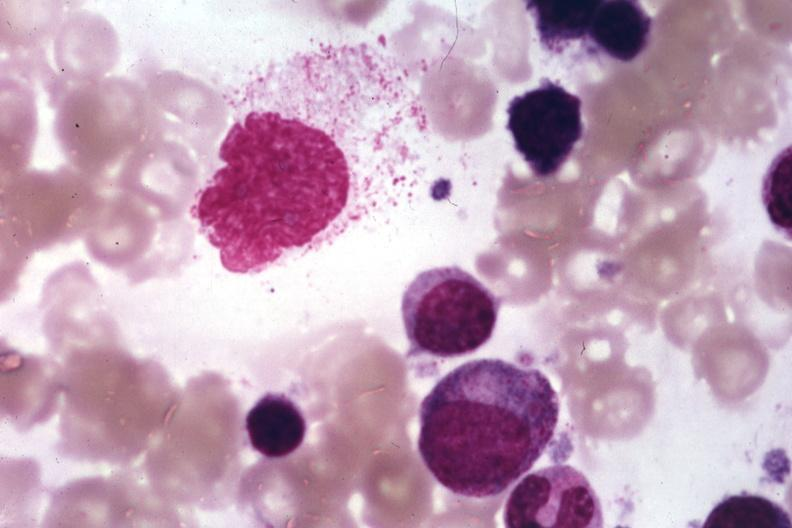s endocervical polyp present?
Answer the question using a single word or phrase. No 